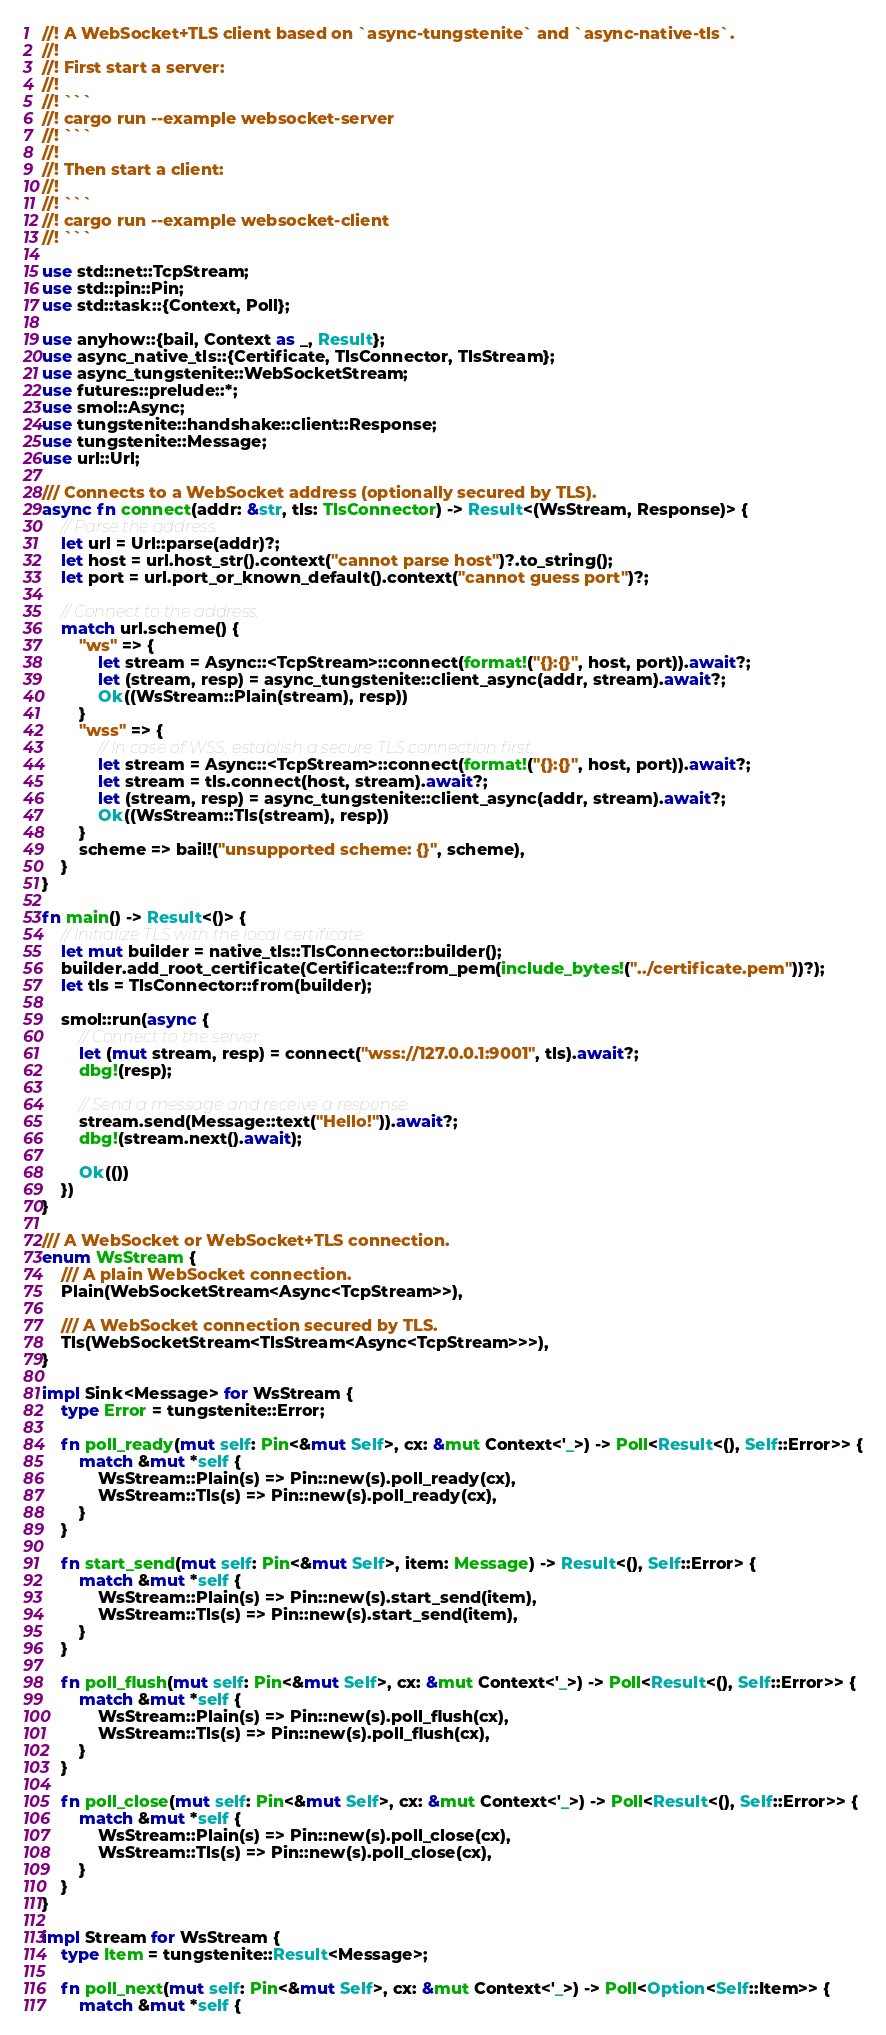<code> <loc_0><loc_0><loc_500><loc_500><_Rust_>//! A WebSocket+TLS client based on `async-tungstenite` and `async-native-tls`.
//!
//! First start a server:
//!
//! ```
//! cargo run --example websocket-server
//! ```
//!
//! Then start a client:
//!
//! ```
//! cargo run --example websocket-client
//! ```

use std::net::TcpStream;
use std::pin::Pin;
use std::task::{Context, Poll};

use anyhow::{bail, Context as _, Result};
use async_native_tls::{Certificate, TlsConnector, TlsStream};
use async_tungstenite::WebSocketStream;
use futures::prelude::*;
use smol::Async;
use tungstenite::handshake::client::Response;
use tungstenite::Message;
use url::Url;

/// Connects to a WebSocket address (optionally secured by TLS).
async fn connect(addr: &str, tls: TlsConnector) -> Result<(WsStream, Response)> {
    // Parse the address.
    let url = Url::parse(addr)?;
    let host = url.host_str().context("cannot parse host")?.to_string();
    let port = url.port_or_known_default().context("cannot guess port")?;

    // Connect to the address.
    match url.scheme() {
        "ws" => {
            let stream = Async::<TcpStream>::connect(format!("{}:{}", host, port)).await?;
            let (stream, resp) = async_tungstenite::client_async(addr, stream).await?;
            Ok((WsStream::Plain(stream), resp))
        }
        "wss" => {
            // In case of WSS, establish a secure TLS connection first.
            let stream = Async::<TcpStream>::connect(format!("{}:{}", host, port)).await?;
            let stream = tls.connect(host, stream).await?;
            let (stream, resp) = async_tungstenite::client_async(addr, stream).await?;
            Ok((WsStream::Tls(stream), resp))
        }
        scheme => bail!("unsupported scheme: {}", scheme),
    }
}

fn main() -> Result<()> {
    // Initialize TLS with the local certificate.
    let mut builder = native_tls::TlsConnector::builder();
    builder.add_root_certificate(Certificate::from_pem(include_bytes!("../certificate.pem"))?);
    let tls = TlsConnector::from(builder);

    smol::run(async {
        // Connect to the server.
        let (mut stream, resp) = connect("wss://127.0.0.1:9001", tls).await?;
        dbg!(resp);

        // Send a message and receive a response.
        stream.send(Message::text("Hello!")).await?;
        dbg!(stream.next().await);

        Ok(())
    })
}

/// A WebSocket or WebSocket+TLS connection.
enum WsStream {
    /// A plain WebSocket connection.
    Plain(WebSocketStream<Async<TcpStream>>),

    /// A WebSocket connection secured by TLS.
    Tls(WebSocketStream<TlsStream<Async<TcpStream>>>),
}

impl Sink<Message> for WsStream {
    type Error = tungstenite::Error;

    fn poll_ready(mut self: Pin<&mut Self>, cx: &mut Context<'_>) -> Poll<Result<(), Self::Error>> {
        match &mut *self {
            WsStream::Plain(s) => Pin::new(s).poll_ready(cx),
            WsStream::Tls(s) => Pin::new(s).poll_ready(cx),
        }
    }

    fn start_send(mut self: Pin<&mut Self>, item: Message) -> Result<(), Self::Error> {
        match &mut *self {
            WsStream::Plain(s) => Pin::new(s).start_send(item),
            WsStream::Tls(s) => Pin::new(s).start_send(item),
        }
    }

    fn poll_flush(mut self: Pin<&mut Self>, cx: &mut Context<'_>) -> Poll<Result<(), Self::Error>> {
        match &mut *self {
            WsStream::Plain(s) => Pin::new(s).poll_flush(cx),
            WsStream::Tls(s) => Pin::new(s).poll_flush(cx),
        }
    }

    fn poll_close(mut self: Pin<&mut Self>, cx: &mut Context<'_>) -> Poll<Result<(), Self::Error>> {
        match &mut *self {
            WsStream::Plain(s) => Pin::new(s).poll_close(cx),
            WsStream::Tls(s) => Pin::new(s).poll_close(cx),
        }
    }
}

impl Stream for WsStream {
    type Item = tungstenite::Result<Message>;

    fn poll_next(mut self: Pin<&mut Self>, cx: &mut Context<'_>) -> Poll<Option<Self::Item>> {
        match &mut *self {</code> 